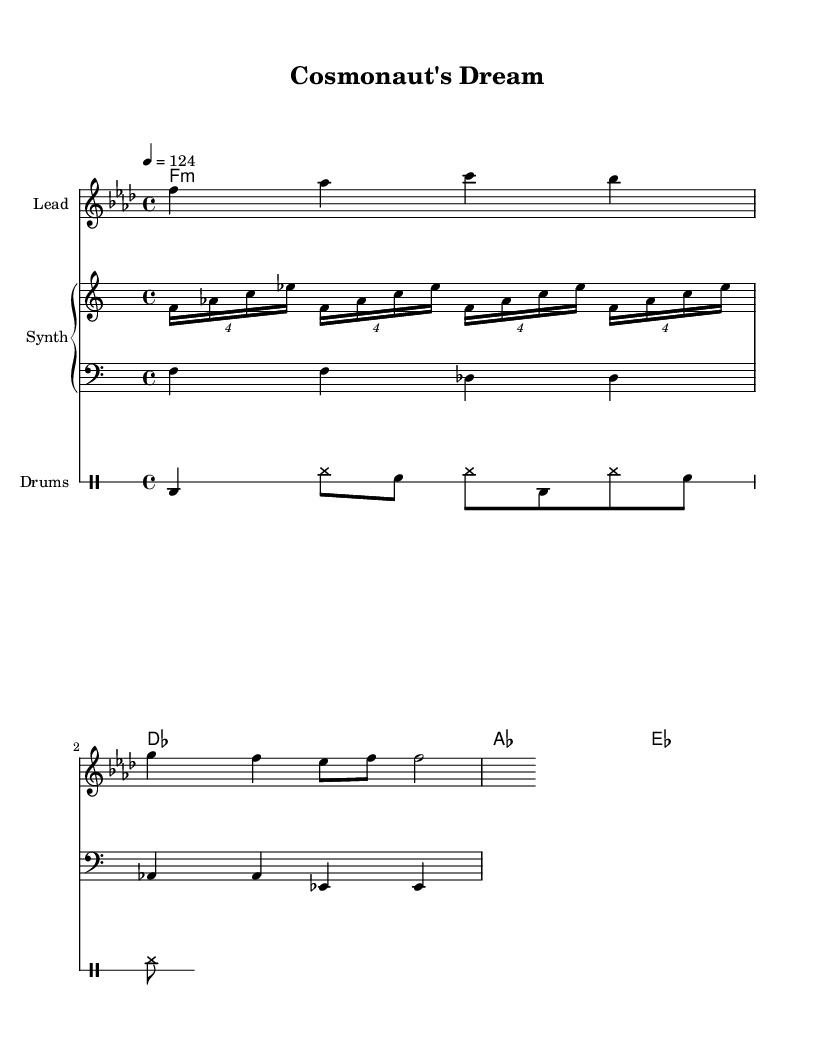What is the key signature of this music? The key signature is determined by the presence of flats or sharps on the staff. In the sheet music, there is a B flat indicated, which corresponds to F minor, the key signature with four flats.
Answer: F minor What is the time signature of this music? The time signature is found at the beginning of the sheet music, indicating how many beats are in each measure. Here, it shows 4/4, meaning there are four beats per measure and the quarter note gets one beat.
Answer: 4/4 What is the tempo marking of this piece? The tempo marking is usually indicated with a number and a note type at the beginning of the sheet music. In this case, it states "4 = 124", implying that a quarter note is played at a speed of 124 beats per minute.
Answer: 124 How many measures are in the melody? By counting the individual measures within the melody section, we find there are four measures represented in the score.
Answer: 4 What type of drum pattern is used in this piece? The drum pattern can be analyzed by examining the specific notation for drums shown in the score. The notation represents a standard kick, hi-hat, and snare configuration, typical for house music.
Answer: Standard pattern What is the bass line's rhythm pattern? The rhythm pattern for the bass line can be understood by looking at its note values and arrangement. It consists of two quarter notes followed by two half notes repeated across two measures, indicating a steady pulse characteristic of house music.
Answer: Steady pulse What is the compositional style of this track? By analyzing the elements presented, such as chord progressions, bass lines, and melodic structure, we can deduce that it features a deep house style, noted for its gradual build and atmospheric depth, often inspired by themes like space exploration.
Answer: Deep house 